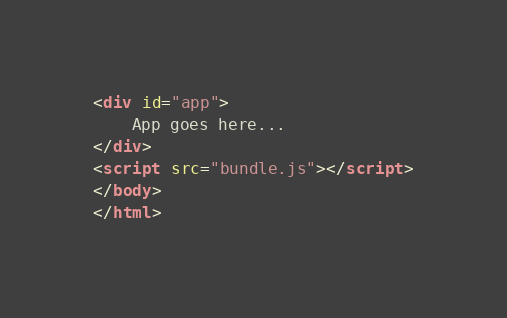Convert code to text. <code><loc_0><loc_0><loc_500><loc_500><_HTML_><div id="app">
    App goes here...
</div>
<script src="bundle.js"></script>
</body>
</html>
</code> 